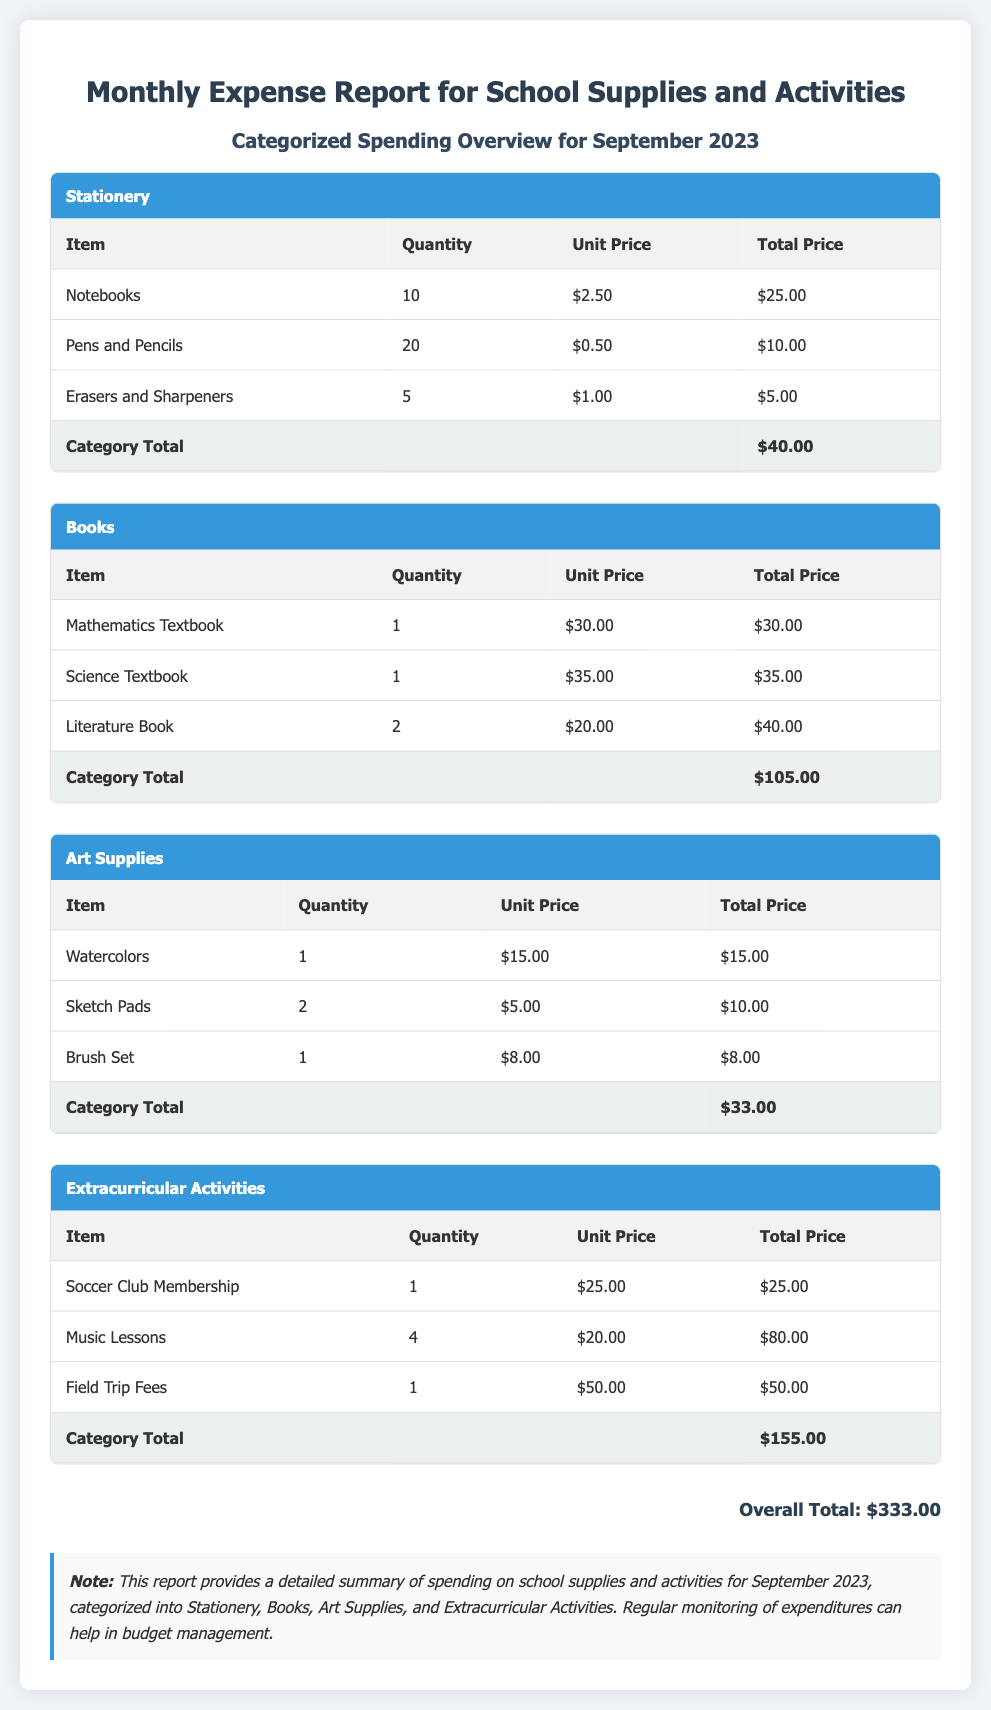What is the total amount spent on Stationery? The total amount spent on Stationery is indicated as the category total in the table, which is $40.00.
Answer: $40.00 How many different categories are listed in the report? The report includes four categories: Stationery, Books, Art Supplies, and Extracurricular Activities.
Answer: Four What is the unit price of the Mathematics Textbook? The unit price of the Mathematics Textbook is listed in the Books section, which is $30.00.
Answer: $30.00 What is the overall total amount spent for September 2023? The overall total can be found at the bottom of the document, which sums all categories to $333.00.
Answer: $333.00 Which category has the highest total spending? Comparing the totals, Extracurricular Activities with $155.00 has the highest spending among the categories.
Answer: Extracurricular Activities How many pens and pencils were purchased? The quantity of Pens and Pencils purchased is provided in the Stationery section of the table, which is 20.
Answer: 20 What is the total for Art Supplies? The total for Art Supplies is specified at the end of that category's section, which is $33.00.
Answer: $33.00 What was the quantity of Literature Books purchased? The quantity of Literature Books purchased is listed under the Books section, which is 2.
Answer: 2 